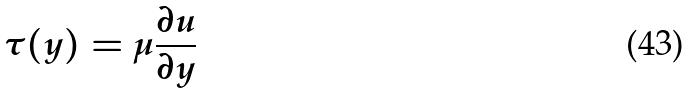<formula> <loc_0><loc_0><loc_500><loc_500>\tau ( y ) = \mu \frac { \partial u } { \partial y }</formula> 